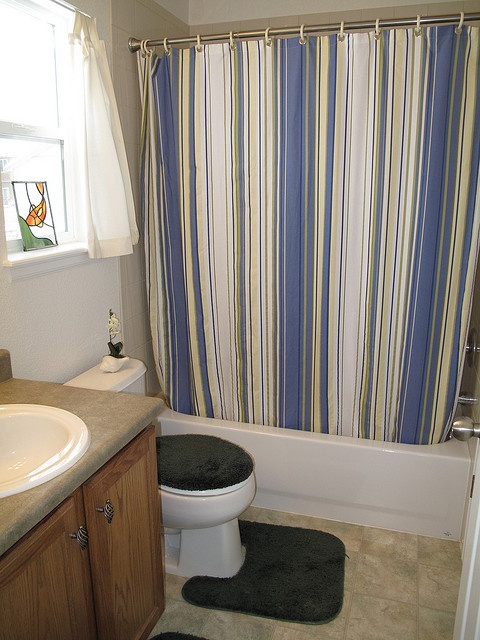Describe the objects in this image and their specific colors. I can see toilet in white, black, and gray tones and sink in white, tan, and lightgray tones in this image. 